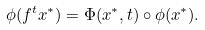Convert formula to latex. <formula><loc_0><loc_0><loc_500><loc_500>\phi ( f ^ { t } x ^ { * } ) = \Phi ( x ^ { * } , t ) \circ \phi ( x ^ { * } ) .</formula> 